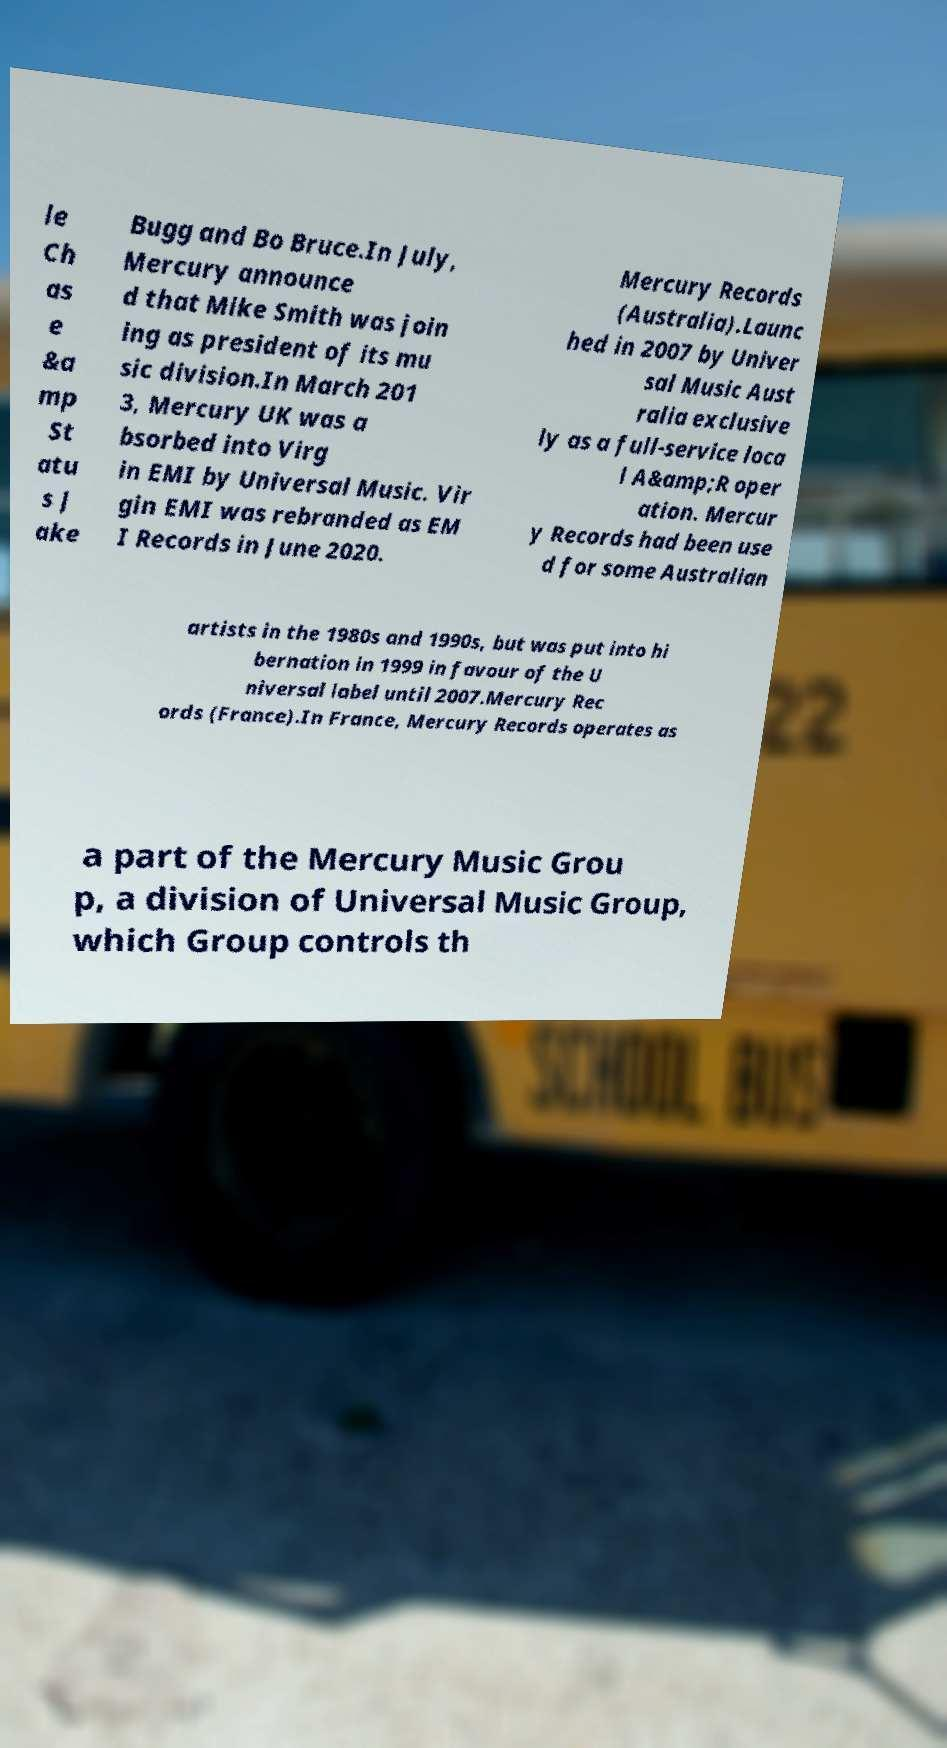I need the written content from this picture converted into text. Can you do that? le Ch as e &a mp St atu s J ake Bugg and Bo Bruce.In July, Mercury announce d that Mike Smith was join ing as president of its mu sic division.In March 201 3, Mercury UK was a bsorbed into Virg in EMI by Universal Music. Vir gin EMI was rebranded as EM I Records in June 2020. Mercury Records (Australia).Launc hed in 2007 by Univer sal Music Aust ralia exclusive ly as a full-service loca l A&amp;R oper ation. Mercur y Records had been use d for some Australian artists in the 1980s and 1990s, but was put into hi bernation in 1999 in favour of the U niversal label until 2007.Mercury Rec ords (France).In France, Mercury Records operates as a part of the Mercury Music Grou p, a division of Universal Music Group, which Group controls th 